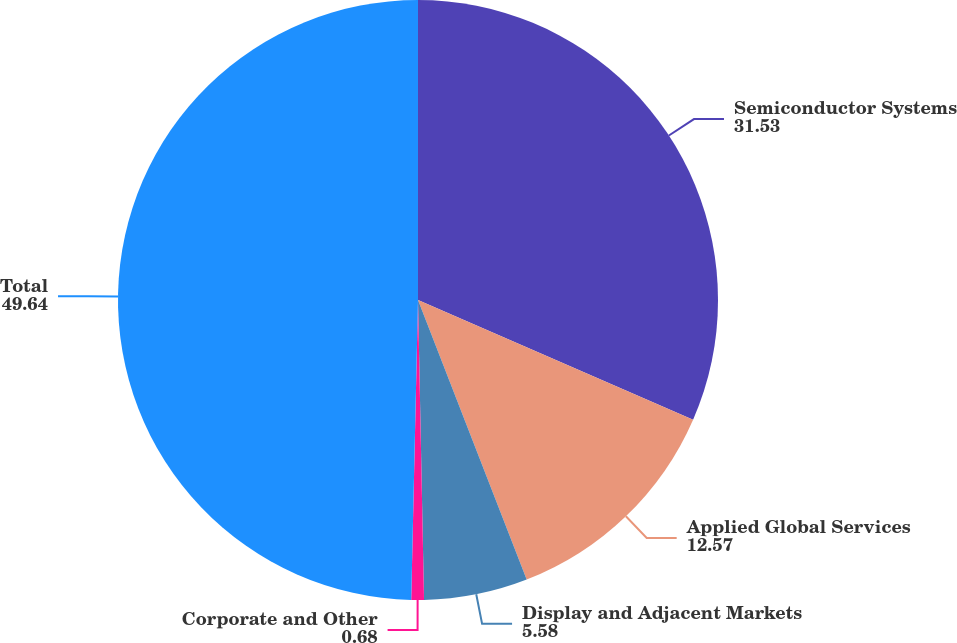Convert chart. <chart><loc_0><loc_0><loc_500><loc_500><pie_chart><fcel>Semiconductor Systems<fcel>Applied Global Services<fcel>Display and Adjacent Markets<fcel>Corporate and Other<fcel>Total<nl><fcel>31.53%<fcel>12.57%<fcel>5.58%<fcel>0.68%<fcel>49.64%<nl></chart> 